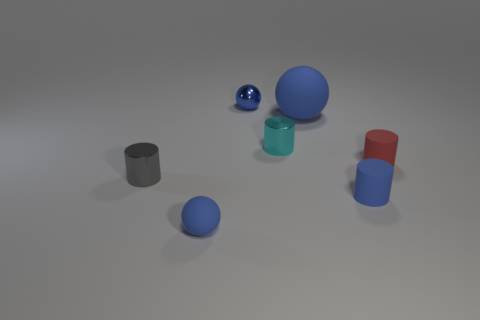Can you describe the lighting and the shadows in the image? The image has soft, diffused lighting that creates gentle shadows beneath each object. The direction of the light appears to be coming from the upper left, as indicated by the shadows leaning towards the bottom right. This gives the scene a calm and uniformly lit appearance, without any harsh highlights or deep shadows. 